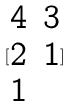Convert formula to latex. <formula><loc_0><loc_0><loc_500><loc_500>[ \begin{matrix} 4 & 3 \\ 2 & 1 \\ 1 \end{matrix} ]</formula> 